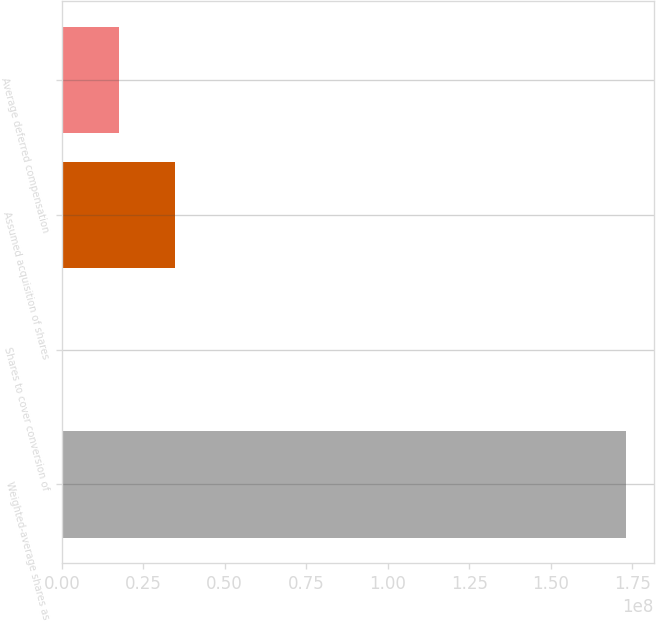Convert chart. <chart><loc_0><loc_0><loc_500><loc_500><bar_chart><fcel>Weighted-average shares as<fcel>Shares to cover conversion of<fcel>Assumed acquisition of shares<fcel>Average deferred compensation<nl><fcel>1.7307e+08<fcel>259451<fcel>3.48215e+07<fcel>1.75405e+07<nl></chart> 